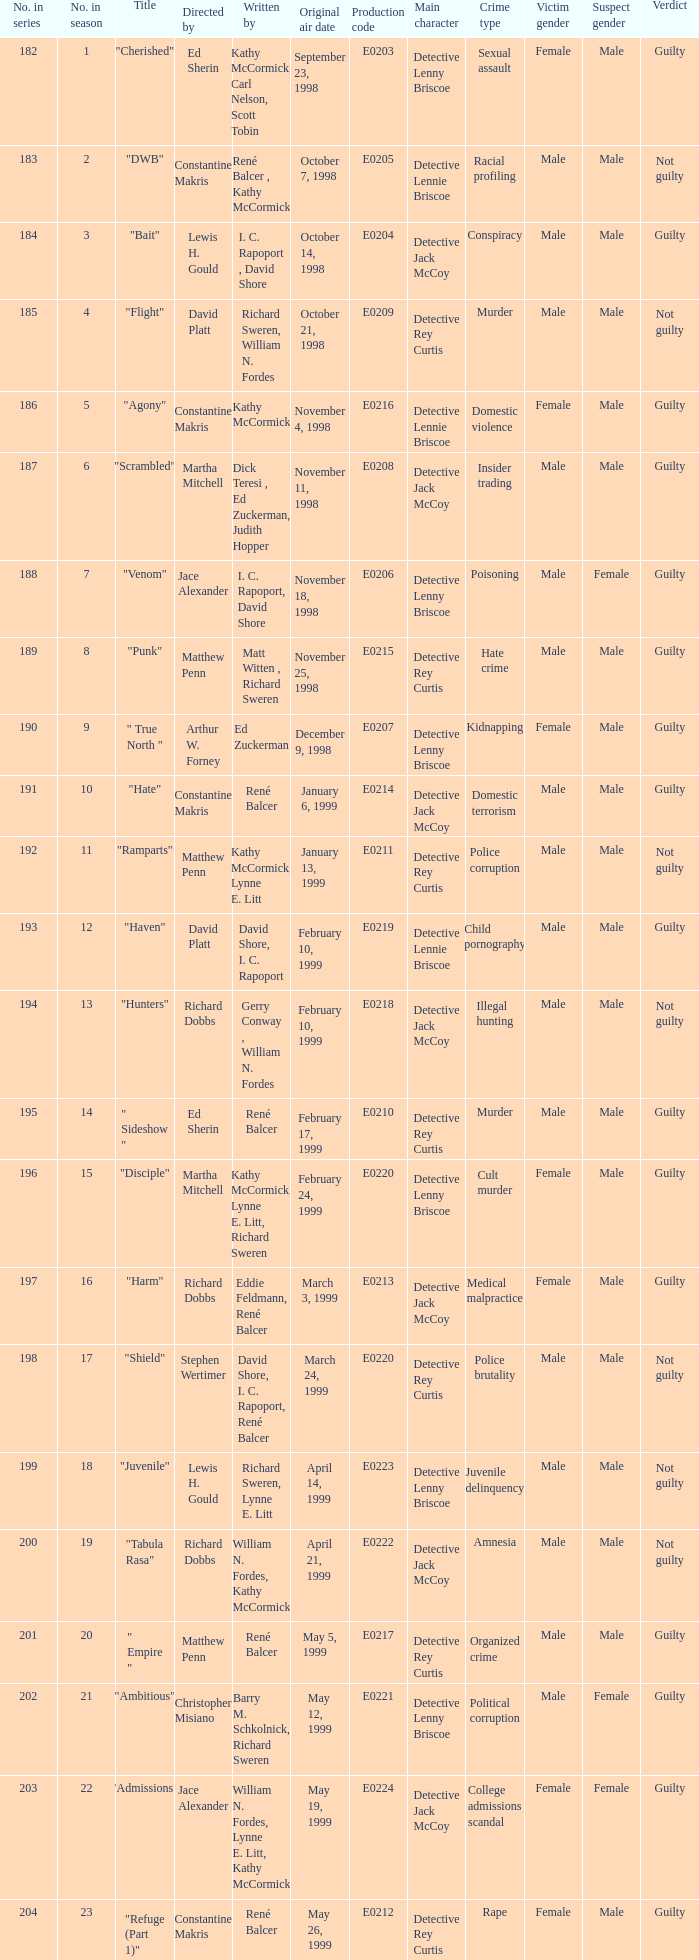The episode with the title "Bait" has what original air date? October 14, 1998. 